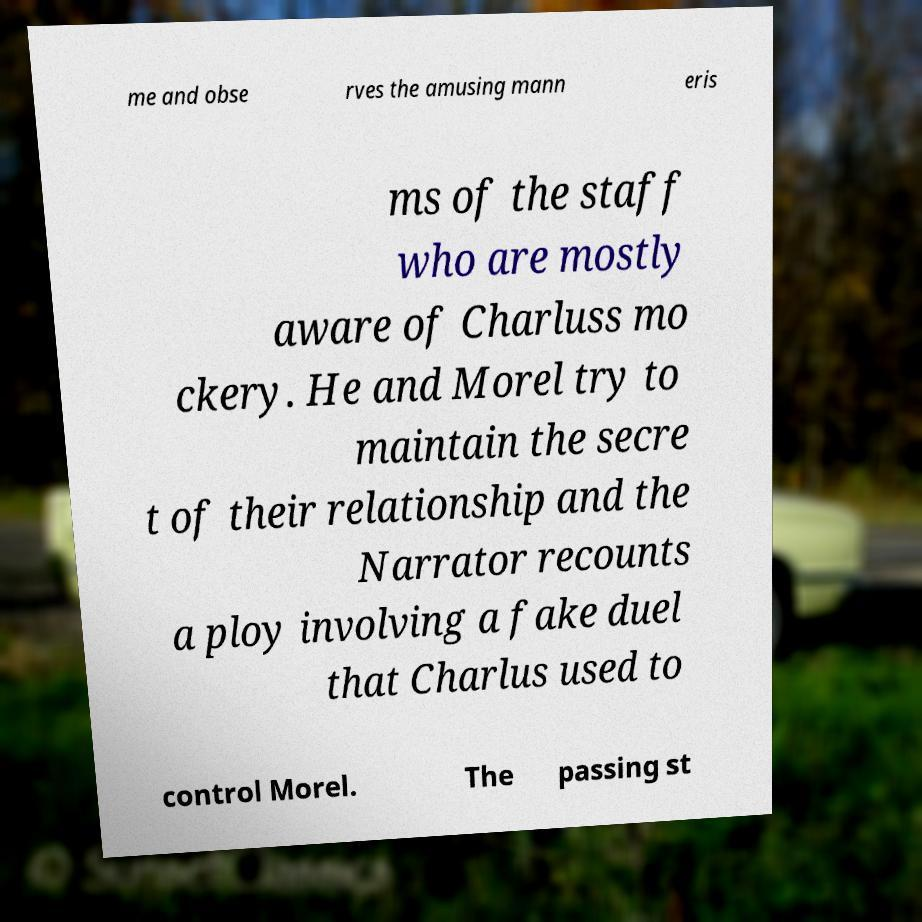What messages or text are displayed in this image? I need them in a readable, typed format. me and obse rves the amusing mann eris ms of the staff who are mostly aware of Charluss mo ckery. He and Morel try to maintain the secre t of their relationship and the Narrator recounts a ploy involving a fake duel that Charlus used to control Morel. The passing st 